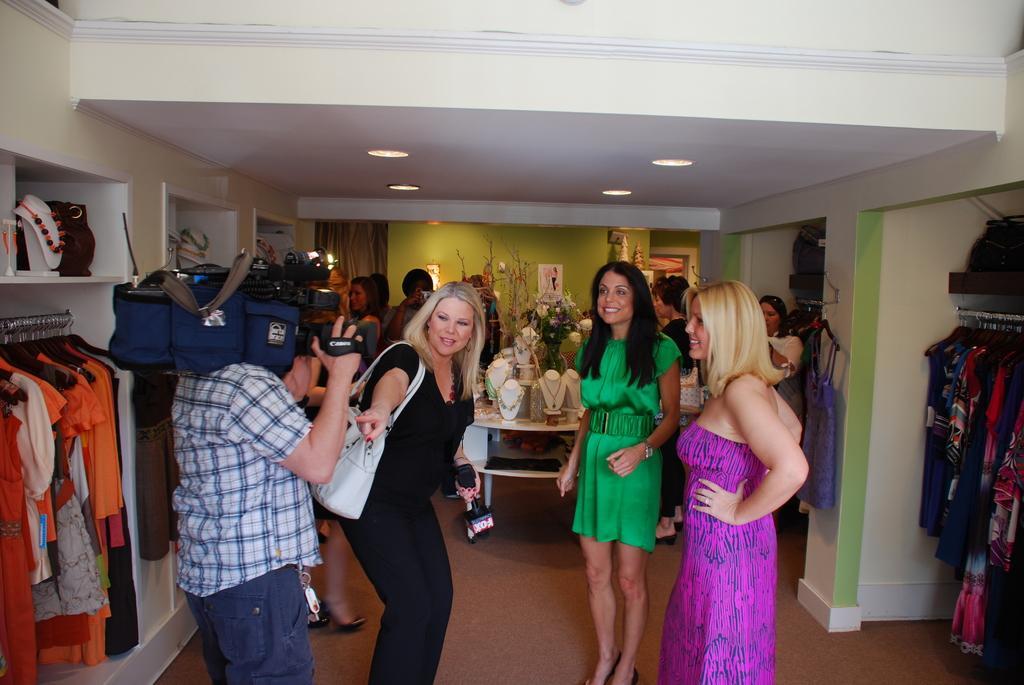Can you describe this image briefly? In the picture I can see a person wearing shirt is holding a camera on his Shoulders, we can see this woman wearing black dress and carrying a handbag is holding a mic in her hand and standing. Here we can see this woman wearing green dress and this woman wearing purple dress are standing on the floor. On the either side of the image we can see dresses hanged to the shelf. In the background, we can see jewelry sets are displayed on the table, we can see flower vase, a few more people standing and the mall to which we can see the photo frames are attached. Here we can see the curtains. 